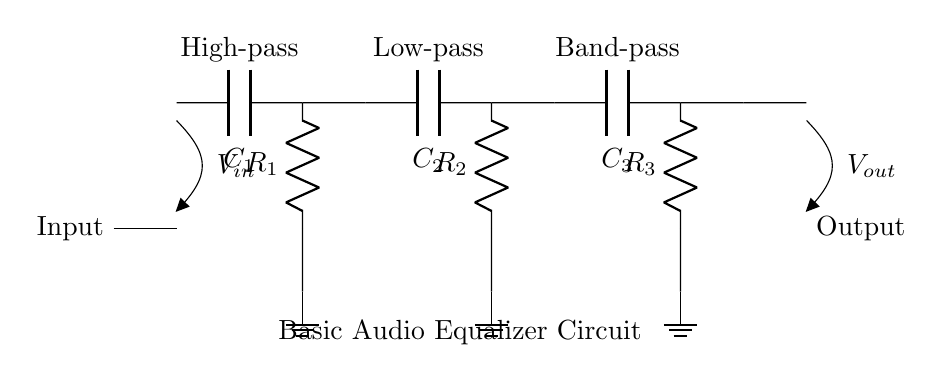What does the input represent in this circuit? The input represents the incoming audio signal that will be processed by the equalizer. It is often labeled as V_in in the circuit diagram, indicating its role as the voltage input.
Answer: V_in What type of components are used for filtering in this circuit? The circuit uses capacitors and resistors to create high-pass, low-pass, and band-pass filters. These components are fundamental in shaping the frequency response of the audio signal.
Answer: Capacitors and resistors How many filters are present in this equalizer circuit? There are three filters present in the circuit: a high-pass filter, a low-pass filter, and a band-pass filter, each serving a different function in processing the audio signal.
Answer: Three What is the role of the capacitor labeled C1? The capacitor C1 is part of the high-pass filter which allows high-frequency signals to pass but blocks lower frequencies. This helps enhance the clarity of high-pitched sounds in the audio.
Answer: High-pass filtering Which component determines the cutoff frequency for the low-pass filter? The cutoff frequency of the low-pass filter is determined by the combination of resistor R2 and capacitor C2. Together, they set the frequency at which the filter begins to attenuate higher frequencies in the audio signal.
Answer: R2 and C2 How is the output of this circuit labeled? The output of the circuit is labeled as V_out, which indicates the processed audio signal that is sent out of the equalizer circuit after filtering.
Answer: V_out What does the ground symbol indicate in this circuit? The ground symbol indicates the reference point for the circuit's voltage levels. It helps complete the circuit and serves as a common return path for the electric current.
Answer: Ground 